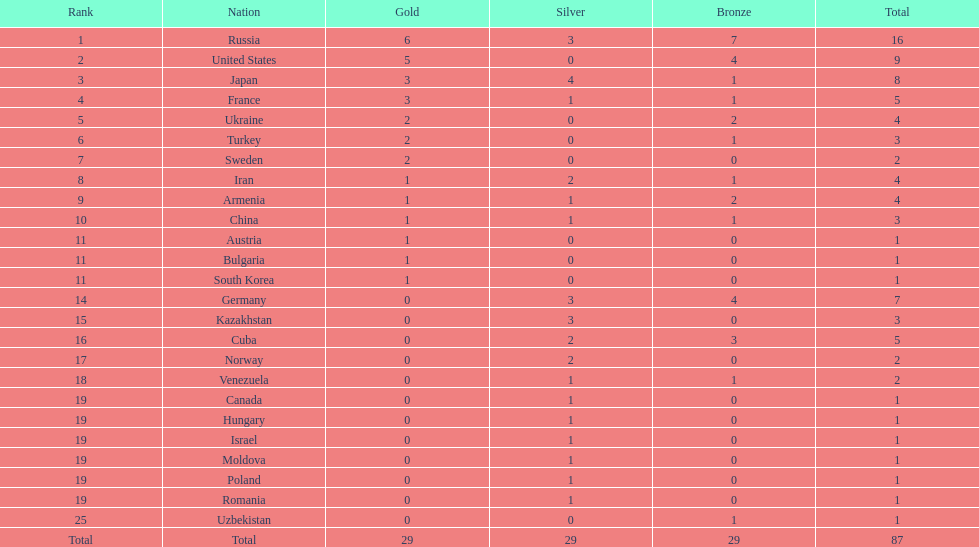Which territory didn't make it to the top 10, iran or germany? Germany. 